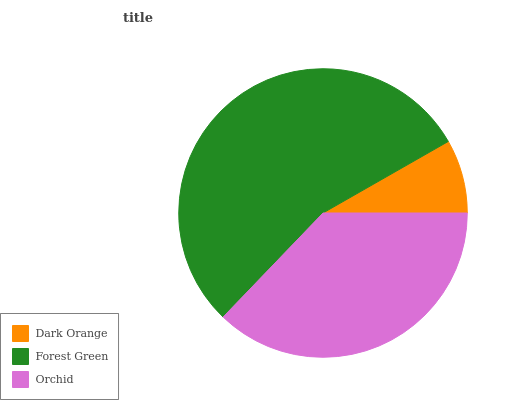Is Dark Orange the minimum?
Answer yes or no. Yes. Is Forest Green the maximum?
Answer yes or no. Yes. Is Orchid the minimum?
Answer yes or no. No. Is Orchid the maximum?
Answer yes or no. No. Is Forest Green greater than Orchid?
Answer yes or no. Yes. Is Orchid less than Forest Green?
Answer yes or no. Yes. Is Orchid greater than Forest Green?
Answer yes or no. No. Is Forest Green less than Orchid?
Answer yes or no. No. Is Orchid the high median?
Answer yes or no. Yes. Is Orchid the low median?
Answer yes or no. Yes. Is Forest Green the high median?
Answer yes or no. No. Is Forest Green the low median?
Answer yes or no. No. 